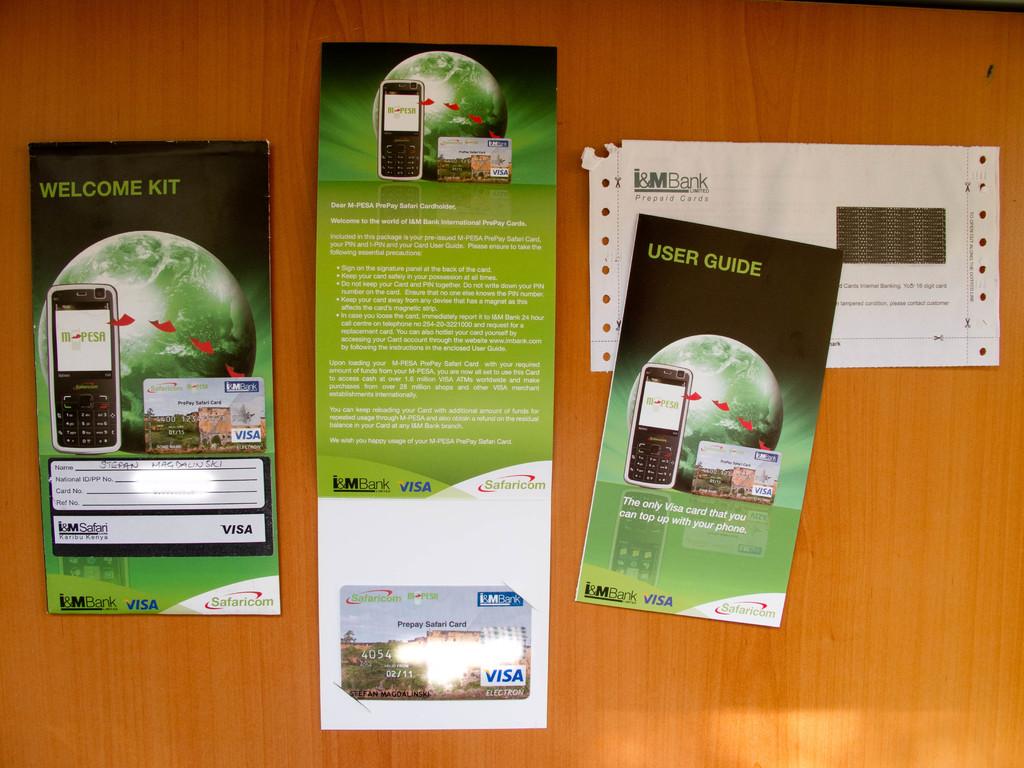Which bank did this card come from?
Offer a very short reply. I&m bank. Does this have a user guide?
Provide a short and direct response. Yes. 